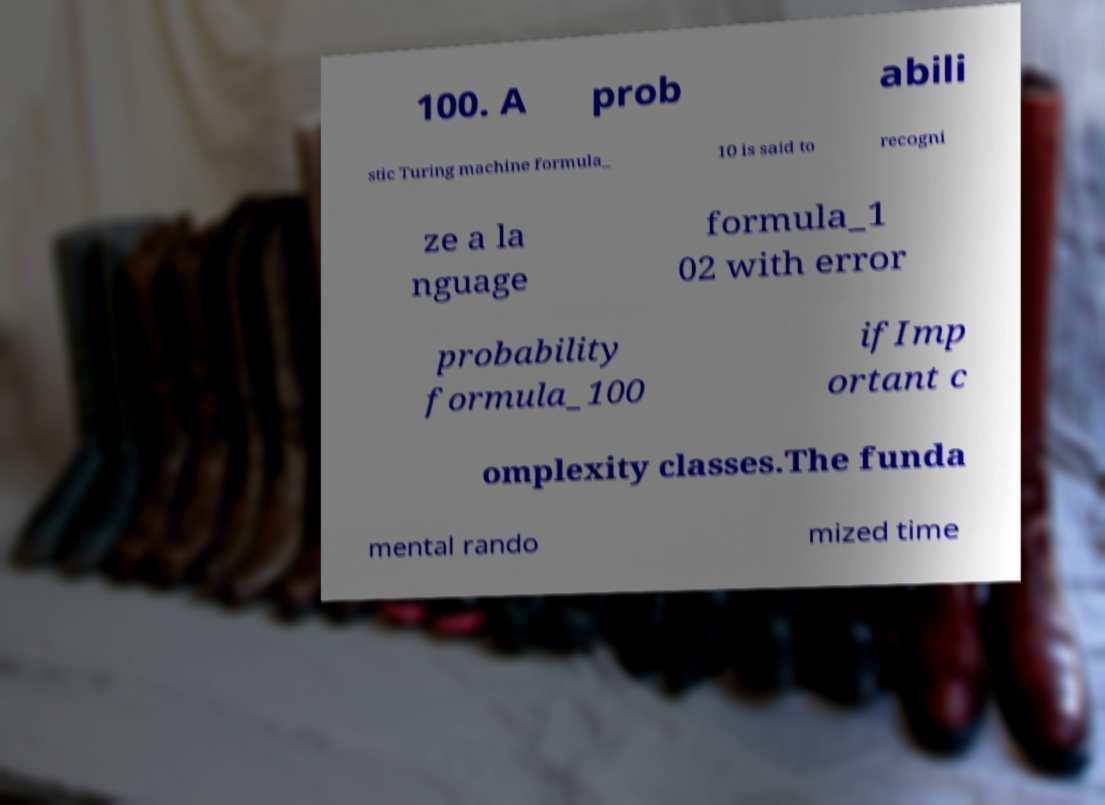I need the written content from this picture converted into text. Can you do that? 100. A prob abili stic Turing machine formula_ 10 is said to recogni ze a la nguage formula_1 02 with error probability formula_100 ifImp ortant c omplexity classes.The funda mental rando mized time 